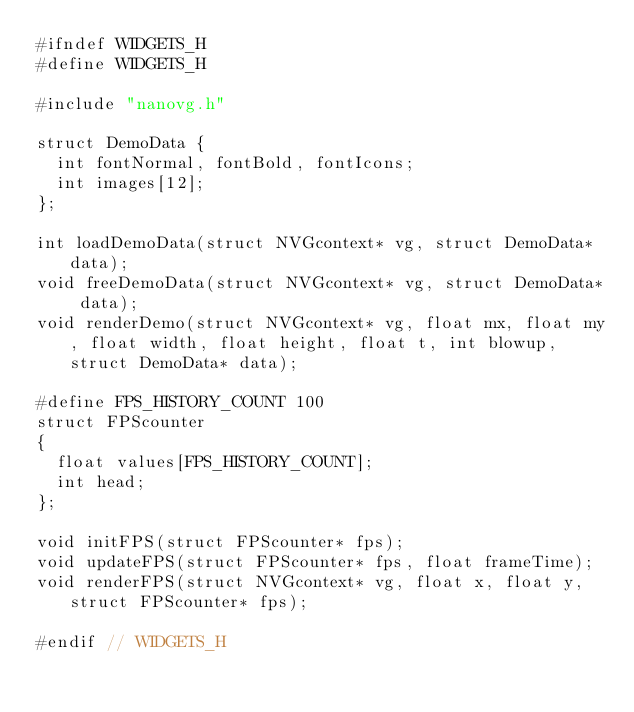<code> <loc_0><loc_0><loc_500><loc_500><_C_>#ifndef WIDGETS_H
#define WIDGETS_H

#include "nanovg.h"

struct DemoData {
	int fontNormal, fontBold, fontIcons; 
	int images[12];
};

int loadDemoData(struct NVGcontext* vg, struct DemoData* data);
void freeDemoData(struct NVGcontext* vg, struct DemoData* data);
void renderDemo(struct NVGcontext* vg, float mx, float my, float width, float height, float t, int blowup, struct DemoData* data);

#define FPS_HISTORY_COUNT 100
struct FPScounter
{
	float values[FPS_HISTORY_COUNT];
	int head;
};

void initFPS(struct FPScounter* fps);
void updateFPS(struct FPScounter* fps, float frameTime);
void renderFPS(struct NVGcontext* vg, float x, float y, struct FPScounter* fps);

#endif // WIDGETS_H</code> 